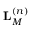Convert formula to latex. <formula><loc_0><loc_0><loc_500><loc_500>L _ { M } ^ { \left ( n \right ) }</formula> 